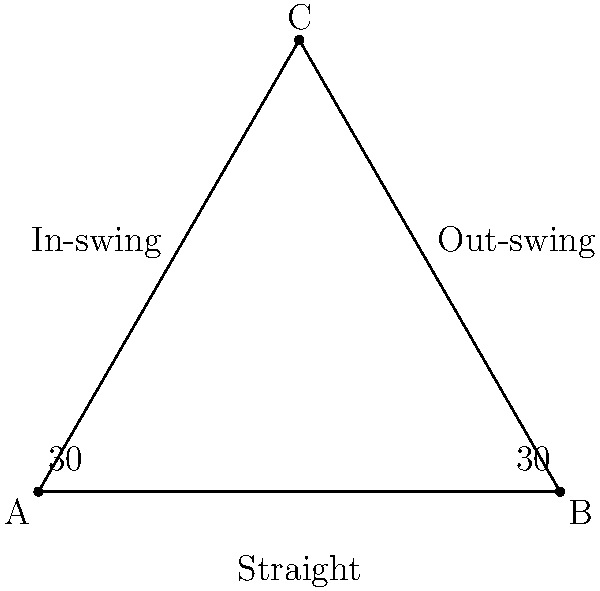In cricket, different bowling deliveries create various angles on the pitch. Look at the triangle ABC, where AB represents a straight delivery, AC an in-swing, and BC an out-swing. If the angle between the straight delivery and both swing deliveries is 30°, what is the measure of angle ACB at the top of the triangle? Let's approach this step-by-step:

1) First, we need to recognize that triangle ABC is an isosceles triangle. This is because:
   - The angle between AB and AC is 30°
   - The angle between AB and BC is also 30°
   - This means AC and BC are equal in length

2) In an isosceles triangle, the angles opposite the equal sides are also equal. So, angle CAB = angle CBA.

3) We know that the sum of angles in a triangle is always 180°.

4) Let's call the measure of angle ACB as x°. We can now set up an equation:
   $$ x° + 30° + 30° = 180° $$

5) Simplifying:
   $$ x° + 60° = 180° $$

6) Subtracting 60° from both sides:
   $$ x° = 120° $$

Therefore, the measure of angle ACB is 120°.
Answer: 120° 